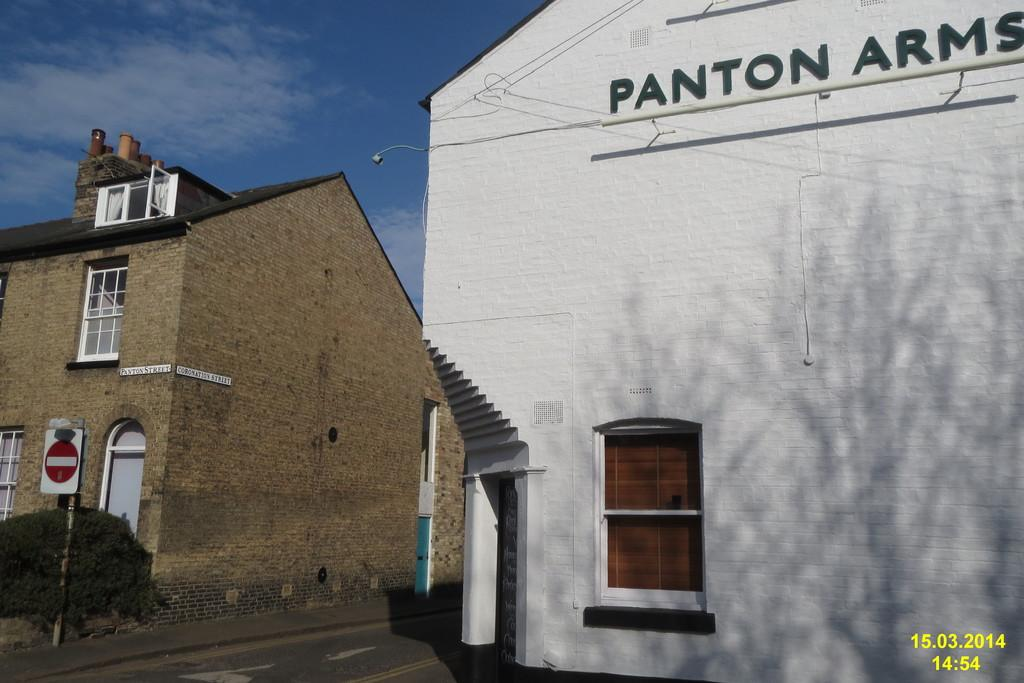<image>
Share a concise interpretation of the image provided. The company name is called pantom arms and is written on the building 